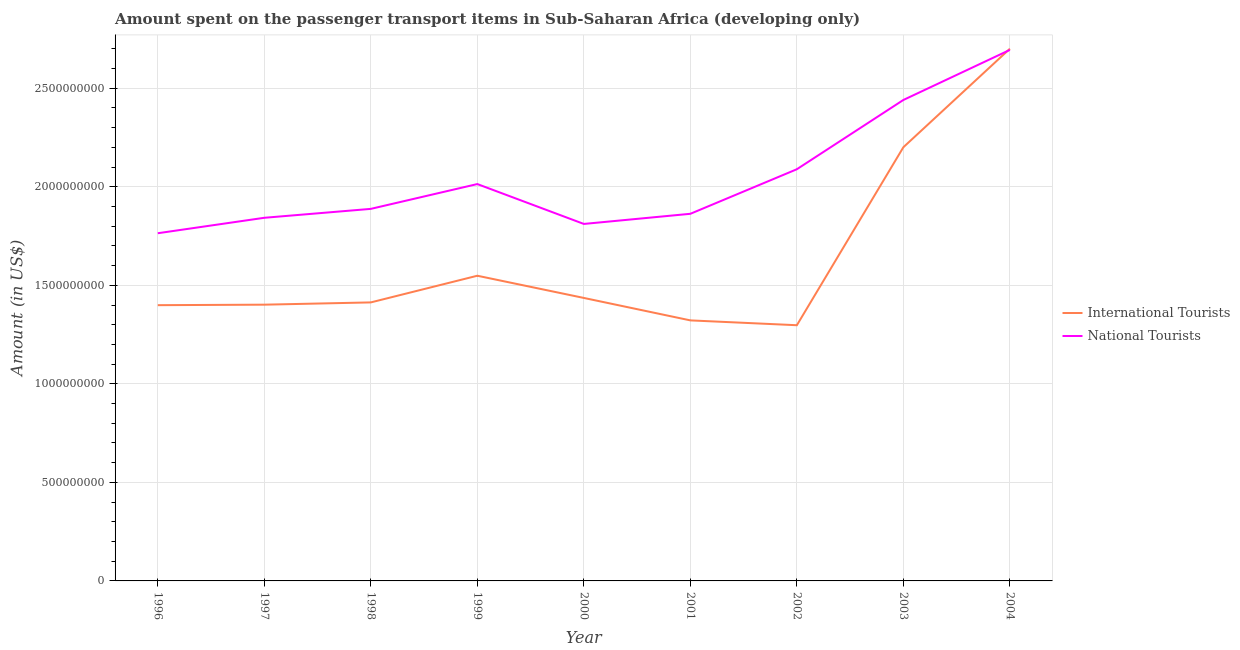Does the line corresponding to amount spent on transport items of international tourists intersect with the line corresponding to amount spent on transport items of national tourists?
Ensure brevity in your answer.  Yes. Is the number of lines equal to the number of legend labels?
Give a very brief answer. Yes. What is the amount spent on transport items of national tourists in 2004?
Your answer should be compact. 2.69e+09. Across all years, what is the maximum amount spent on transport items of national tourists?
Make the answer very short. 2.69e+09. Across all years, what is the minimum amount spent on transport items of national tourists?
Your answer should be very brief. 1.76e+09. In which year was the amount spent on transport items of national tourists minimum?
Your answer should be very brief. 1996. What is the total amount spent on transport items of international tourists in the graph?
Give a very brief answer. 1.47e+1. What is the difference between the amount spent on transport items of international tourists in 1997 and that in 2000?
Offer a very short reply. -3.42e+07. What is the difference between the amount spent on transport items of international tourists in 1999 and the amount spent on transport items of national tourists in 2004?
Make the answer very short. -1.15e+09. What is the average amount spent on transport items of national tourists per year?
Your answer should be very brief. 2.05e+09. In the year 1997, what is the difference between the amount spent on transport items of international tourists and amount spent on transport items of national tourists?
Give a very brief answer. -4.41e+08. In how many years, is the amount spent on transport items of international tourists greater than 2300000000 US$?
Offer a terse response. 1. What is the ratio of the amount spent on transport items of national tourists in 1997 to that in 2001?
Your answer should be compact. 0.99. Is the difference between the amount spent on transport items of national tourists in 1996 and 2004 greater than the difference between the amount spent on transport items of international tourists in 1996 and 2004?
Ensure brevity in your answer.  Yes. What is the difference between the highest and the second highest amount spent on transport items of national tourists?
Your answer should be very brief. 2.54e+08. What is the difference between the highest and the lowest amount spent on transport items of national tourists?
Your response must be concise. 9.30e+08. In how many years, is the amount spent on transport items of international tourists greater than the average amount spent on transport items of international tourists taken over all years?
Make the answer very short. 2. Does the amount spent on transport items of national tourists monotonically increase over the years?
Provide a short and direct response. No. How many lines are there?
Give a very brief answer. 2. How many years are there in the graph?
Provide a succinct answer. 9. Does the graph contain any zero values?
Give a very brief answer. No. Does the graph contain grids?
Offer a very short reply. Yes. Where does the legend appear in the graph?
Ensure brevity in your answer.  Center right. How are the legend labels stacked?
Your answer should be very brief. Vertical. What is the title of the graph?
Your response must be concise. Amount spent on the passenger transport items in Sub-Saharan Africa (developing only). Does "By country of asylum" appear as one of the legend labels in the graph?
Your answer should be very brief. No. What is the label or title of the Y-axis?
Offer a terse response. Amount (in US$). What is the Amount (in US$) of International Tourists in 1996?
Your response must be concise. 1.40e+09. What is the Amount (in US$) of National Tourists in 1996?
Your answer should be compact. 1.76e+09. What is the Amount (in US$) in International Tourists in 1997?
Your answer should be compact. 1.40e+09. What is the Amount (in US$) in National Tourists in 1997?
Your answer should be very brief. 1.84e+09. What is the Amount (in US$) in International Tourists in 1998?
Keep it short and to the point. 1.41e+09. What is the Amount (in US$) in National Tourists in 1998?
Give a very brief answer. 1.89e+09. What is the Amount (in US$) in International Tourists in 1999?
Provide a short and direct response. 1.55e+09. What is the Amount (in US$) in National Tourists in 1999?
Your answer should be very brief. 2.01e+09. What is the Amount (in US$) of International Tourists in 2000?
Make the answer very short. 1.44e+09. What is the Amount (in US$) in National Tourists in 2000?
Your response must be concise. 1.81e+09. What is the Amount (in US$) of International Tourists in 2001?
Give a very brief answer. 1.32e+09. What is the Amount (in US$) in National Tourists in 2001?
Give a very brief answer. 1.86e+09. What is the Amount (in US$) in International Tourists in 2002?
Offer a terse response. 1.30e+09. What is the Amount (in US$) in National Tourists in 2002?
Provide a short and direct response. 2.09e+09. What is the Amount (in US$) of International Tourists in 2003?
Make the answer very short. 2.20e+09. What is the Amount (in US$) of National Tourists in 2003?
Your answer should be very brief. 2.44e+09. What is the Amount (in US$) of International Tourists in 2004?
Make the answer very short. 2.70e+09. What is the Amount (in US$) in National Tourists in 2004?
Your answer should be very brief. 2.69e+09. Across all years, what is the maximum Amount (in US$) in International Tourists?
Provide a short and direct response. 2.70e+09. Across all years, what is the maximum Amount (in US$) in National Tourists?
Offer a very short reply. 2.69e+09. Across all years, what is the minimum Amount (in US$) in International Tourists?
Offer a terse response. 1.30e+09. Across all years, what is the minimum Amount (in US$) of National Tourists?
Give a very brief answer. 1.76e+09. What is the total Amount (in US$) in International Tourists in the graph?
Your answer should be compact. 1.47e+1. What is the total Amount (in US$) of National Tourists in the graph?
Keep it short and to the point. 1.84e+1. What is the difference between the Amount (in US$) in International Tourists in 1996 and that in 1997?
Your answer should be compact. -2.49e+06. What is the difference between the Amount (in US$) of National Tourists in 1996 and that in 1997?
Keep it short and to the point. -7.84e+07. What is the difference between the Amount (in US$) of International Tourists in 1996 and that in 1998?
Give a very brief answer. -1.40e+07. What is the difference between the Amount (in US$) in National Tourists in 1996 and that in 1998?
Make the answer very short. -1.24e+08. What is the difference between the Amount (in US$) of International Tourists in 1996 and that in 1999?
Give a very brief answer. -1.49e+08. What is the difference between the Amount (in US$) of National Tourists in 1996 and that in 1999?
Keep it short and to the point. -2.50e+08. What is the difference between the Amount (in US$) of International Tourists in 1996 and that in 2000?
Ensure brevity in your answer.  -3.67e+07. What is the difference between the Amount (in US$) in National Tourists in 1996 and that in 2000?
Keep it short and to the point. -4.72e+07. What is the difference between the Amount (in US$) in International Tourists in 1996 and that in 2001?
Provide a short and direct response. 7.72e+07. What is the difference between the Amount (in US$) in National Tourists in 1996 and that in 2001?
Keep it short and to the point. -9.86e+07. What is the difference between the Amount (in US$) in International Tourists in 1996 and that in 2002?
Your answer should be compact. 1.02e+08. What is the difference between the Amount (in US$) of National Tourists in 1996 and that in 2002?
Offer a terse response. -3.25e+08. What is the difference between the Amount (in US$) in International Tourists in 1996 and that in 2003?
Your answer should be compact. -8.01e+08. What is the difference between the Amount (in US$) in National Tourists in 1996 and that in 2003?
Your answer should be compact. -6.76e+08. What is the difference between the Amount (in US$) in International Tourists in 1996 and that in 2004?
Offer a very short reply. -1.30e+09. What is the difference between the Amount (in US$) of National Tourists in 1996 and that in 2004?
Provide a short and direct response. -9.30e+08. What is the difference between the Amount (in US$) in International Tourists in 1997 and that in 1998?
Offer a very short reply. -1.15e+07. What is the difference between the Amount (in US$) of National Tourists in 1997 and that in 1998?
Give a very brief answer. -4.52e+07. What is the difference between the Amount (in US$) in International Tourists in 1997 and that in 1999?
Make the answer very short. -1.47e+08. What is the difference between the Amount (in US$) of National Tourists in 1997 and that in 1999?
Keep it short and to the point. -1.71e+08. What is the difference between the Amount (in US$) in International Tourists in 1997 and that in 2000?
Provide a short and direct response. -3.42e+07. What is the difference between the Amount (in US$) of National Tourists in 1997 and that in 2000?
Provide a succinct answer. 3.12e+07. What is the difference between the Amount (in US$) of International Tourists in 1997 and that in 2001?
Your answer should be very brief. 7.97e+07. What is the difference between the Amount (in US$) of National Tourists in 1997 and that in 2001?
Your answer should be compact. -2.02e+07. What is the difference between the Amount (in US$) of International Tourists in 1997 and that in 2002?
Your answer should be very brief. 1.04e+08. What is the difference between the Amount (in US$) in National Tourists in 1997 and that in 2002?
Provide a short and direct response. -2.46e+08. What is the difference between the Amount (in US$) in International Tourists in 1997 and that in 2003?
Offer a very short reply. -7.99e+08. What is the difference between the Amount (in US$) of National Tourists in 1997 and that in 2003?
Offer a very short reply. -5.98e+08. What is the difference between the Amount (in US$) of International Tourists in 1997 and that in 2004?
Provide a succinct answer. -1.30e+09. What is the difference between the Amount (in US$) in National Tourists in 1997 and that in 2004?
Give a very brief answer. -8.52e+08. What is the difference between the Amount (in US$) of International Tourists in 1998 and that in 1999?
Ensure brevity in your answer.  -1.35e+08. What is the difference between the Amount (in US$) of National Tourists in 1998 and that in 1999?
Ensure brevity in your answer.  -1.26e+08. What is the difference between the Amount (in US$) of International Tourists in 1998 and that in 2000?
Keep it short and to the point. -2.27e+07. What is the difference between the Amount (in US$) of National Tourists in 1998 and that in 2000?
Your answer should be very brief. 7.65e+07. What is the difference between the Amount (in US$) of International Tourists in 1998 and that in 2001?
Offer a very short reply. 9.12e+07. What is the difference between the Amount (in US$) of National Tourists in 1998 and that in 2001?
Your response must be concise. 2.50e+07. What is the difference between the Amount (in US$) of International Tourists in 1998 and that in 2002?
Your answer should be compact. 1.16e+08. What is the difference between the Amount (in US$) in National Tourists in 1998 and that in 2002?
Offer a very short reply. -2.01e+08. What is the difference between the Amount (in US$) of International Tourists in 1998 and that in 2003?
Ensure brevity in your answer.  -7.87e+08. What is the difference between the Amount (in US$) in National Tourists in 1998 and that in 2003?
Your answer should be very brief. -5.53e+08. What is the difference between the Amount (in US$) of International Tourists in 1998 and that in 2004?
Ensure brevity in your answer.  -1.29e+09. What is the difference between the Amount (in US$) of National Tourists in 1998 and that in 2004?
Offer a very short reply. -8.07e+08. What is the difference between the Amount (in US$) in International Tourists in 1999 and that in 2000?
Offer a very short reply. 1.13e+08. What is the difference between the Amount (in US$) in National Tourists in 1999 and that in 2000?
Your response must be concise. 2.02e+08. What is the difference between the Amount (in US$) of International Tourists in 1999 and that in 2001?
Provide a succinct answer. 2.27e+08. What is the difference between the Amount (in US$) of National Tourists in 1999 and that in 2001?
Provide a short and direct response. 1.51e+08. What is the difference between the Amount (in US$) in International Tourists in 1999 and that in 2002?
Offer a terse response. 2.51e+08. What is the difference between the Amount (in US$) of National Tourists in 1999 and that in 2002?
Offer a very short reply. -7.53e+07. What is the difference between the Amount (in US$) in International Tourists in 1999 and that in 2003?
Provide a succinct answer. -6.52e+08. What is the difference between the Amount (in US$) in National Tourists in 1999 and that in 2003?
Provide a short and direct response. -4.27e+08. What is the difference between the Amount (in US$) in International Tourists in 1999 and that in 2004?
Offer a very short reply. -1.15e+09. What is the difference between the Amount (in US$) in National Tourists in 1999 and that in 2004?
Your response must be concise. -6.81e+08. What is the difference between the Amount (in US$) in International Tourists in 2000 and that in 2001?
Your response must be concise. 1.14e+08. What is the difference between the Amount (in US$) in National Tourists in 2000 and that in 2001?
Give a very brief answer. -5.15e+07. What is the difference between the Amount (in US$) in International Tourists in 2000 and that in 2002?
Give a very brief answer. 1.38e+08. What is the difference between the Amount (in US$) of National Tourists in 2000 and that in 2002?
Provide a short and direct response. -2.78e+08. What is the difference between the Amount (in US$) in International Tourists in 2000 and that in 2003?
Your answer should be compact. -7.65e+08. What is the difference between the Amount (in US$) in National Tourists in 2000 and that in 2003?
Give a very brief answer. -6.29e+08. What is the difference between the Amount (in US$) of International Tourists in 2000 and that in 2004?
Provide a short and direct response. -1.26e+09. What is the difference between the Amount (in US$) in National Tourists in 2000 and that in 2004?
Give a very brief answer. -8.83e+08. What is the difference between the Amount (in US$) of International Tourists in 2001 and that in 2002?
Your response must be concise. 2.45e+07. What is the difference between the Amount (in US$) of National Tourists in 2001 and that in 2002?
Your answer should be compact. -2.26e+08. What is the difference between the Amount (in US$) of International Tourists in 2001 and that in 2003?
Ensure brevity in your answer.  -8.79e+08. What is the difference between the Amount (in US$) in National Tourists in 2001 and that in 2003?
Your answer should be very brief. -5.78e+08. What is the difference between the Amount (in US$) of International Tourists in 2001 and that in 2004?
Offer a terse response. -1.38e+09. What is the difference between the Amount (in US$) of National Tourists in 2001 and that in 2004?
Your answer should be compact. -8.32e+08. What is the difference between the Amount (in US$) of International Tourists in 2002 and that in 2003?
Ensure brevity in your answer.  -9.03e+08. What is the difference between the Amount (in US$) in National Tourists in 2002 and that in 2003?
Your answer should be compact. -3.52e+08. What is the difference between the Amount (in US$) of International Tourists in 2002 and that in 2004?
Your answer should be compact. -1.40e+09. What is the difference between the Amount (in US$) of National Tourists in 2002 and that in 2004?
Your answer should be very brief. -6.06e+08. What is the difference between the Amount (in US$) of International Tourists in 2003 and that in 2004?
Provide a short and direct response. -5.00e+08. What is the difference between the Amount (in US$) in National Tourists in 2003 and that in 2004?
Ensure brevity in your answer.  -2.54e+08. What is the difference between the Amount (in US$) in International Tourists in 1996 and the Amount (in US$) in National Tourists in 1997?
Make the answer very short. -4.43e+08. What is the difference between the Amount (in US$) in International Tourists in 1996 and the Amount (in US$) in National Tourists in 1998?
Provide a succinct answer. -4.89e+08. What is the difference between the Amount (in US$) of International Tourists in 1996 and the Amount (in US$) of National Tourists in 1999?
Your answer should be compact. -6.15e+08. What is the difference between the Amount (in US$) of International Tourists in 1996 and the Amount (in US$) of National Tourists in 2000?
Offer a terse response. -4.12e+08. What is the difference between the Amount (in US$) in International Tourists in 1996 and the Amount (in US$) in National Tourists in 2001?
Provide a short and direct response. -4.64e+08. What is the difference between the Amount (in US$) in International Tourists in 1996 and the Amount (in US$) in National Tourists in 2002?
Give a very brief answer. -6.90e+08. What is the difference between the Amount (in US$) of International Tourists in 1996 and the Amount (in US$) of National Tourists in 2003?
Offer a terse response. -1.04e+09. What is the difference between the Amount (in US$) of International Tourists in 1996 and the Amount (in US$) of National Tourists in 2004?
Your answer should be very brief. -1.30e+09. What is the difference between the Amount (in US$) of International Tourists in 1997 and the Amount (in US$) of National Tourists in 1998?
Ensure brevity in your answer.  -4.86e+08. What is the difference between the Amount (in US$) in International Tourists in 1997 and the Amount (in US$) in National Tourists in 1999?
Make the answer very short. -6.12e+08. What is the difference between the Amount (in US$) in International Tourists in 1997 and the Amount (in US$) in National Tourists in 2000?
Offer a very short reply. -4.10e+08. What is the difference between the Amount (in US$) in International Tourists in 1997 and the Amount (in US$) in National Tourists in 2001?
Provide a short and direct response. -4.61e+08. What is the difference between the Amount (in US$) of International Tourists in 1997 and the Amount (in US$) of National Tourists in 2002?
Make the answer very short. -6.87e+08. What is the difference between the Amount (in US$) in International Tourists in 1997 and the Amount (in US$) in National Tourists in 2003?
Keep it short and to the point. -1.04e+09. What is the difference between the Amount (in US$) in International Tourists in 1997 and the Amount (in US$) in National Tourists in 2004?
Provide a succinct answer. -1.29e+09. What is the difference between the Amount (in US$) of International Tourists in 1998 and the Amount (in US$) of National Tourists in 1999?
Your answer should be compact. -6.01e+08. What is the difference between the Amount (in US$) in International Tourists in 1998 and the Amount (in US$) in National Tourists in 2000?
Make the answer very short. -3.98e+08. What is the difference between the Amount (in US$) in International Tourists in 1998 and the Amount (in US$) in National Tourists in 2001?
Ensure brevity in your answer.  -4.50e+08. What is the difference between the Amount (in US$) in International Tourists in 1998 and the Amount (in US$) in National Tourists in 2002?
Provide a succinct answer. -6.76e+08. What is the difference between the Amount (in US$) of International Tourists in 1998 and the Amount (in US$) of National Tourists in 2003?
Give a very brief answer. -1.03e+09. What is the difference between the Amount (in US$) of International Tourists in 1998 and the Amount (in US$) of National Tourists in 2004?
Your answer should be compact. -1.28e+09. What is the difference between the Amount (in US$) in International Tourists in 1999 and the Amount (in US$) in National Tourists in 2000?
Ensure brevity in your answer.  -2.63e+08. What is the difference between the Amount (in US$) of International Tourists in 1999 and the Amount (in US$) of National Tourists in 2001?
Offer a terse response. -3.14e+08. What is the difference between the Amount (in US$) in International Tourists in 1999 and the Amount (in US$) in National Tourists in 2002?
Your answer should be very brief. -5.40e+08. What is the difference between the Amount (in US$) in International Tourists in 1999 and the Amount (in US$) in National Tourists in 2003?
Offer a very short reply. -8.92e+08. What is the difference between the Amount (in US$) of International Tourists in 1999 and the Amount (in US$) of National Tourists in 2004?
Offer a very short reply. -1.15e+09. What is the difference between the Amount (in US$) of International Tourists in 2000 and the Amount (in US$) of National Tourists in 2001?
Your response must be concise. -4.27e+08. What is the difference between the Amount (in US$) of International Tourists in 2000 and the Amount (in US$) of National Tourists in 2002?
Make the answer very short. -6.53e+08. What is the difference between the Amount (in US$) of International Tourists in 2000 and the Amount (in US$) of National Tourists in 2003?
Provide a short and direct response. -1.00e+09. What is the difference between the Amount (in US$) of International Tourists in 2000 and the Amount (in US$) of National Tourists in 2004?
Provide a short and direct response. -1.26e+09. What is the difference between the Amount (in US$) in International Tourists in 2001 and the Amount (in US$) in National Tourists in 2002?
Your response must be concise. -7.67e+08. What is the difference between the Amount (in US$) of International Tourists in 2001 and the Amount (in US$) of National Tourists in 2003?
Give a very brief answer. -1.12e+09. What is the difference between the Amount (in US$) of International Tourists in 2001 and the Amount (in US$) of National Tourists in 2004?
Offer a very short reply. -1.37e+09. What is the difference between the Amount (in US$) of International Tourists in 2002 and the Amount (in US$) of National Tourists in 2003?
Give a very brief answer. -1.14e+09. What is the difference between the Amount (in US$) of International Tourists in 2002 and the Amount (in US$) of National Tourists in 2004?
Ensure brevity in your answer.  -1.40e+09. What is the difference between the Amount (in US$) in International Tourists in 2003 and the Amount (in US$) in National Tourists in 2004?
Make the answer very short. -4.94e+08. What is the average Amount (in US$) of International Tourists per year?
Your response must be concise. 1.64e+09. What is the average Amount (in US$) of National Tourists per year?
Your answer should be very brief. 2.05e+09. In the year 1996, what is the difference between the Amount (in US$) of International Tourists and Amount (in US$) of National Tourists?
Your answer should be compact. -3.65e+08. In the year 1997, what is the difference between the Amount (in US$) in International Tourists and Amount (in US$) in National Tourists?
Your answer should be very brief. -4.41e+08. In the year 1998, what is the difference between the Amount (in US$) in International Tourists and Amount (in US$) in National Tourists?
Offer a very short reply. -4.75e+08. In the year 1999, what is the difference between the Amount (in US$) of International Tourists and Amount (in US$) of National Tourists?
Keep it short and to the point. -4.65e+08. In the year 2000, what is the difference between the Amount (in US$) of International Tourists and Amount (in US$) of National Tourists?
Offer a very short reply. -3.76e+08. In the year 2001, what is the difference between the Amount (in US$) of International Tourists and Amount (in US$) of National Tourists?
Offer a very short reply. -5.41e+08. In the year 2002, what is the difference between the Amount (in US$) of International Tourists and Amount (in US$) of National Tourists?
Give a very brief answer. -7.92e+08. In the year 2003, what is the difference between the Amount (in US$) of International Tourists and Amount (in US$) of National Tourists?
Keep it short and to the point. -2.40e+08. In the year 2004, what is the difference between the Amount (in US$) of International Tourists and Amount (in US$) of National Tourists?
Offer a terse response. 6.05e+06. What is the ratio of the Amount (in US$) in National Tourists in 1996 to that in 1997?
Provide a succinct answer. 0.96. What is the ratio of the Amount (in US$) in International Tourists in 1996 to that in 1998?
Your answer should be very brief. 0.99. What is the ratio of the Amount (in US$) of National Tourists in 1996 to that in 1998?
Keep it short and to the point. 0.93. What is the ratio of the Amount (in US$) of International Tourists in 1996 to that in 1999?
Give a very brief answer. 0.9. What is the ratio of the Amount (in US$) of National Tourists in 1996 to that in 1999?
Offer a very short reply. 0.88. What is the ratio of the Amount (in US$) in International Tourists in 1996 to that in 2000?
Offer a very short reply. 0.97. What is the ratio of the Amount (in US$) in International Tourists in 1996 to that in 2001?
Offer a terse response. 1.06. What is the ratio of the Amount (in US$) of National Tourists in 1996 to that in 2001?
Keep it short and to the point. 0.95. What is the ratio of the Amount (in US$) of International Tourists in 1996 to that in 2002?
Keep it short and to the point. 1.08. What is the ratio of the Amount (in US$) of National Tourists in 1996 to that in 2002?
Your answer should be compact. 0.84. What is the ratio of the Amount (in US$) of International Tourists in 1996 to that in 2003?
Keep it short and to the point. 0.64. What is the ratio of the Amount (in US$) in National Tourists in 1996 to that in 2003?
Your answer should be compact. 0.72. What is the ratio of the Amount (in US$) in International Tourists in 1996 to that in 2004?
Offer a terse response. 0.52. What is the ratio of the Amount (in US$) of National Tourists in 1996 to that in 2004?
Ensure brevity in your answer.  0.65. What is the ratio of the Amount (in US$) of National Tourists in 1997 to that in 1998?
Offer a very short reply. 0.98. What is the ratio of the Amount (in US$) in International Tourists in 1997 to that in 1999?
Your answer should be compact. 0.91. What is the ratio of the Amount (in US$) of National Tourists in 1997 to that in 1999?
Keep it short and to the point. 0.92. What is the ratio of the Amount (in US$) in International Tourists in 1997 to that in 2000?
Make the answer very short. 0.98. What is the ratio of the Amount (in US$) of National Tourists in 1997 to that in 2000?
Your answer should be very brief. 1.02. What is the ratio of the Amount (in US$) of International Tourists in 1997 to that in 2001?
Keep it short and to the point. 1.06. What is the ratio of the Amount (in US$) of International Tourists in 1997 to that in 2002?
Ensure brevity in your answer.  1.08. What is the ratio of the Amount (in US$) of National Tourists in 1997 to that in 2002?
Your response must be concise. 0.88. What is the ratio of the Amount (in US$) of International Tourists in 1997 to that in 2003?
Your answer should be very brief. 0.64. What is the ratio of the Amount (in US$) of National Tourists in 1997 to that in 2003?
Keep it short and to the point. 0.76. What is the ratio of the Amount (in US$) of International Tourists in 1997 to that in 2004?
Give a very brief answer. 0.52. What is the ratio of the Amount (in US$) of National Tourists in 1997 to that in 2004?
Give a very brief answer. 0.68. What is the ratio of the Amount (in US$) in International Tourists in 1998 to that in 1999?
Your response must be concise. 0.91. What is the ratio of the Amount (in US$) of International Tourists in 1998 to that in 2000?
Your answer should be very brief. 0.98. What is the ratio of the Amount (in US$) in National Tourists in 1998 to that in 2000?
Provide a succinct answer. 1.04. What is the ratio of the Amount (in US$) in International Tourists in 1998 to that in 2001?
Your response must be concise. 1.07. What is the ratio of the Amount (in US$) in National Tourists in 1998 to that in 2001?
Provide a short and direct response. 1.01. What is the ratio of the Amount (in US$) of International Tourists in 1998 to that in 2002?
Give a very brief answer. 1.09. What is the ratio of the Amount (in US$) of National Tourists in 1998 to that in 2002?
Your answer should be very brief. 0.9. What is the ratio of the Amount (in US$) of International Tourists in 1998 to that in 2003?
Offer a very short reply. 0.64. What is the ratio of the Amount (in US$) of National Tourists in 1998 to that in 2003?
Give a very brief answer. 0.77. What is the ratio of the Amount (in US$) of International Tourists in 1998 to that in 2004?
Offer a very short reply. 0.52. What is the ratio of the Amount (in US$) of National Tourists in 1998 to that in 2004?
Make the answer very short. 0.7. What is the ratio of the Amount (in US$) of International Tourists in 1999 to that in 2000?
Make the answer very short. 1.08. What is the ratio of the Amount (in US$) of National Tourists in 1999 to that in 2000?
Your answer should be compact. 1.11. What is the ratio of the Amount (in US$) in International Tourists in 1999 to that in 2001?
Your response must be concise. 1.17. What is the ratio of the Amount (in US$) in National Tourists in 1999 to that in 2001?
Offer a very short reply. 1.08. What is the ratio of the Amount (in US$) of International Tourists in 1999 to that in 2002?
Provide a succinct answer. 1.19. What is the ratio of the Amount (in US$) in International Tourists in 1999 to that in 2003?
Give a very brief answer. 0.7. What is the ratio of the Amount (in US$) of National Tourists in 1999 to that in 2003?
Provide a succinct answer. 0.83. What is the ratio of the Amount (in US$) of International Tourists in 1999 to that in 2004?
Your answer should be compact. 0.57. What is the ratio of the Amount (in US$) of National Tourists in 1999 to that in 2004?
Your answer should be very brief. 0.75. What is the ratio of the Amount (in US$) of International Tourists in 2000 to that in 2001?
Offer a very short reply. 1.09. What is the ratio of the Amount (in US$) in National Tourists in 2000 to that in 2001?
Offer a terse response. 0.97. What is the ratio of the Amount (in US$) in International Tourists in 2000 to that in 2002?
Your response must be concise. 1.11. What is the ratio of the Amount (in US$) in National Tourists in 2000 to that in 2002?
Ensure brevity in your answer.  0.87. What is the ratio of the Amount (in US$) in International Tourists in 2000 to that in 2003?
Your answer should be very brief. 0.65. What is the ratio of the Amount (in US$) in National Tourists in 2000 to that in 2003?
Your answer should be very brief. 0.74. What is the ratio of the Amount (in US$) in International Tourists in 2000 to that in 2004?
Provide a succinct answer. 0.53. What is the ratio of the Amount (in US$) in National Tourists in 2000 to that in 2004?
Keep it short and to the point. 0.67. What is the ratio of the Amount (in US$) in International Tourists in 2001 to that in 2002?
Your answer should be compact. 1.02. What is the ratio of the Amount (in US$) of National Tourists in 2001 to that in 2002?
Give a very brief answer. 0.89. What is the ratio of the Amount (in US$) of International Tourists in 2001 to that in 2003?
Provide a succinct answer. 0.6. What is the ratio of the Amount (in US$) of National Tourists in 2001 to that in 2003?
Provide a short and direct response. 0.76. What is the ratio of the Amount (in US$) of International Tourists in 2001 to that in 2004?
Your answer should be very brief. 0.49. What is the ratio of the Amount (in US$) of National Tourists in 2001 to that in 2004?
Your response must be concise. 0.69. What is the ratio of the Amount (in US$) in International Tourists in 2002 to that in 2003?
Keep it short and to the point. 0.59. What is the ratio of the Amount (in US$) of National Tourists in 2002 to that in 2003?
Your answer should be very brief. 0.86. What is the ratio of the Amount (in US$) in International Tourists in 2002 to that in 2004?
Offer a terse response. 0.48. What is the ratio of the Amount (in US$) in National Tourists in 2002 to that in 2004?
Ensure brevity in your answer.  0.78. What is the ratio of the Amount (in US$) in International Tourists in 2003 to that in 2004?
Give a very brief answer. 0.81. What is the ratio of the Amount (in US$) in National Tourists in 2003 to that in 2004?
Your answer should be compact. 0.91. What is the difference between the highest and the second highest Amount (in US$) of International Tourists?
Your response must be concise. 5.00e+08. What is the difference between the highest and the second highest Amount (in US$) of National Tourists?
Give a very brief answer. 2.54e+08. What is the difference between the highest and the lowest Amount (in US$) of International Tourists?
Offer a very short reply. 1.40e+09. What is the difference between the highest and the lowest Amount (in US$) of National Tourists?
Offer a very short reply. 9.30e+08. 